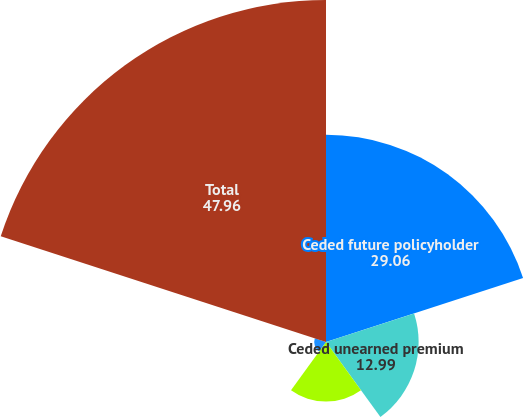Convert chart. <chart><loc_0><loc_0><loc_500><loc_500><pie_chart><fcel>Ceded future policyholder<fcel>Ceded unearned premium<fcel>Ceded claims and benefits<fcel>Ceded paid losses<fcel>Total<nl><fcel>29.06%<fcel>12.99%<fcel>8.35%<fcel>1.65%<fcel>47.96%<nl></chart> 